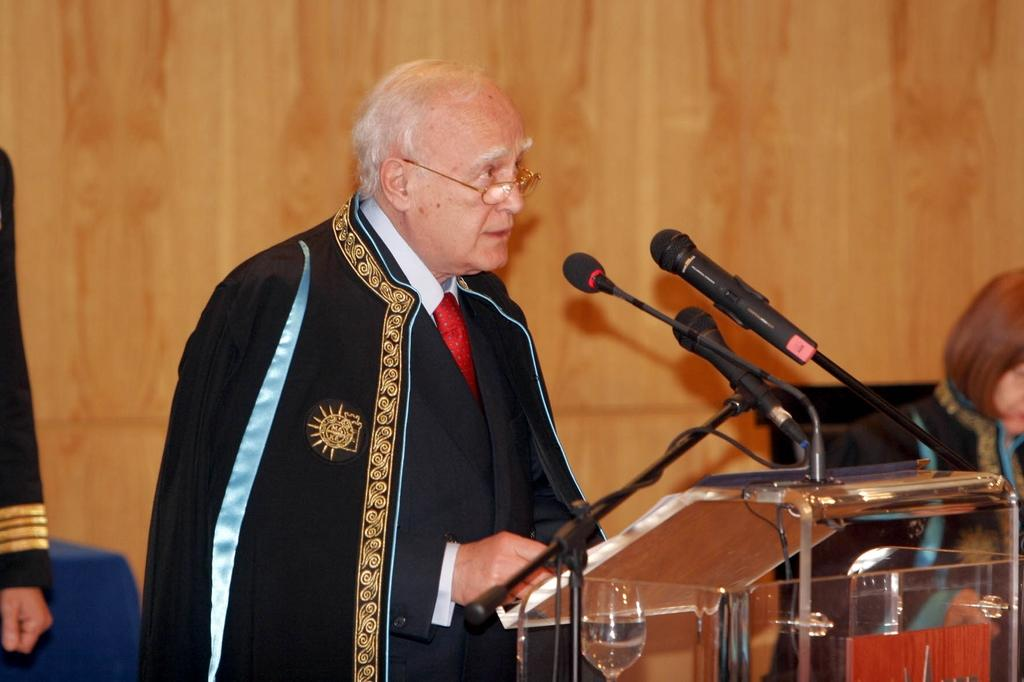Who is the main subject in the image? The main subject in the image is an old man. What is the old man wearing? The old man is wearing a black dress. Where is the old man standing in the image? The old man is standing in front of a dias. What is the old man doing in the image? The old man is talking on a mic. Are there any other people visible in the image? Yes, there are two persons visible on either side of the old man. What can be seen in the background of the image? There is a wooden wall in the background of the image. Reasoning: Let' Let's think step by step in order to produce the conversation. We start by identifying the main subject in the image, which is the old man. Then, we describe the old man's appearance and location in the image. Next, we focus on the old man's actions, specifically mentioning that he is talking on a mic. We then acknowledge the presence of other people in the image and describe the background setting. Absurd Question/Answer: What type of tree is growing in the background of the image? There is no tree visible in the background of the image; it features a wooden wall. What valuable jewel can be seen on the old man's hand in the image? There is no jewel visible on the old man's hand in the image. 